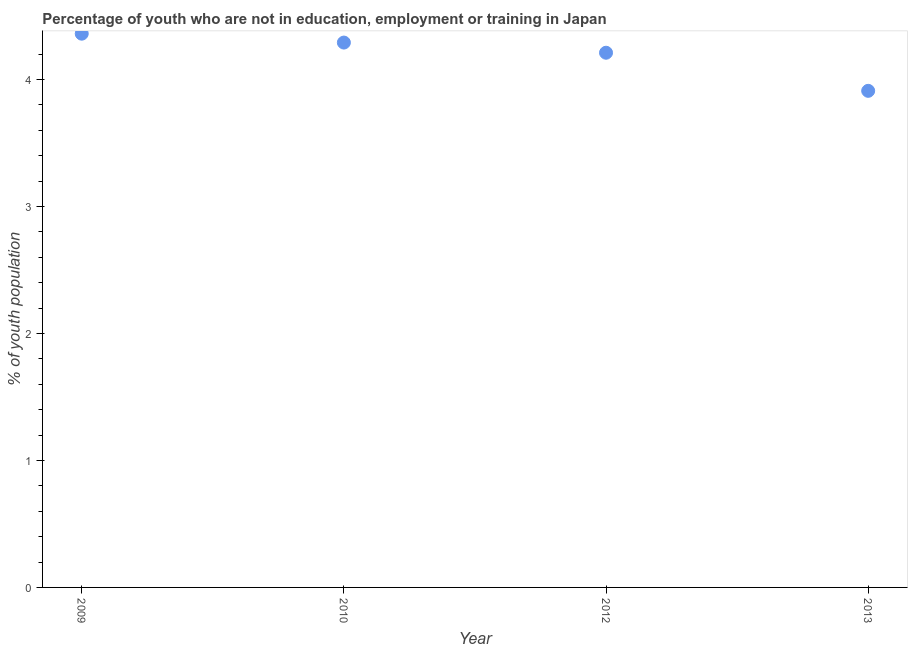What is the unemployed youth population in 2009?
Keep it short and to the point. 4.36. Across all years, what is the maximum unemployed youth population?
Offer a very short reply. 4.36. Across all years, what is the minimum unemployed youth population?
Offer a terse response. 3.91. In which year was the unemployed youth population maximum?
Your answer should be compact. 2009. What is the sum of the unemployed youth population?
Keep it short and to the point. 16.77. What is the difference between the unemployed youth population in 2009 and 2013?
Make the answer very short. 0.45. What is the average unemployed youth population per year?
Keep it short and to the point. 4.19. What is the median unemployed youth population?
Your answer should be compact. 4.25. In how many years, is the unemployed youth population greater than 3 %?
Give a very brief answer. 4. What is the ratio of the unemployed youth population in 2009 to that in 2010?
Give a very brief answer. 1.02. Is the unemployed youth population in 2010 less than that in 2013?
Offer a terse response. No. What is the difference between the highest and the second highest unemployed youth population?
Your answer should be compact. 0.07. Is the sum of the unemployed youth population in 2009 and 2013 greater than the maximum unemployed youth population across all years?
Your response must be concise. Yes. What is the difference between the highest and the lowest unemployed youth population?
Give a very brief answer. 0.45. How many years are there in the graph?
Offer a terse response. 4. Are the values on the major ticks of Y-axis written in scientific E-notation?
Keep it short and to the point. No. What is the title of the graph?
Your response must be concise. Percentage of youth who are not in education, employment or training in Japan. What is the label or title of the Y-axis?
Offer a terse response. % of youth population. What is the % of youth population in 2009?
Your response must be concise. 4.36. What is the % of youth population in 2010?
Provide a succinct answer. 4.29. What is the % of youth population in 2012?
Make the answer very short. 4.21. What is the % of youth population in 2013?
Your answer should be very brief. 3.91. What is the difference between the % of youth population in 2009 and 2010?
Your response must be concise. 0.07. What is the difference between the % of youth population in 2009 and 2013?
Make the answer very short. 0.45. What is the difference between the % of youth population in 2010 and 2013?
Give a very brief answer. 0.38. What is the ratio of the % of youth population in 2009 to that in 2012?
Provide a succinct answer. 1.04. What is the ratio of the % of youth population in 2009 to that in 2013?
Give a very brief answer. 1.11. What is the ratio of the % of youth population in 2010 to that in 2012?
Ensure brevity in your answer.  1.02. What is the ratio of the % of youth population in 2010 to that in 2013?
Provide a succinct answer. 1.1. What is the ratio of the % of youth population in 2012 to that in 2013?
Make the answer very short. 1.08. 